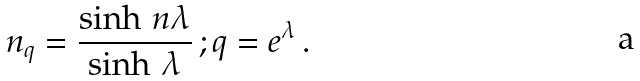<formula> <loc_0><loc_0><loc_500><loc_500>n _ { q } = \frac { \sinh \, n \lambda } { \sinh \, \lambda } \, ; q = e ^ { \lambda } \, .</formula> 